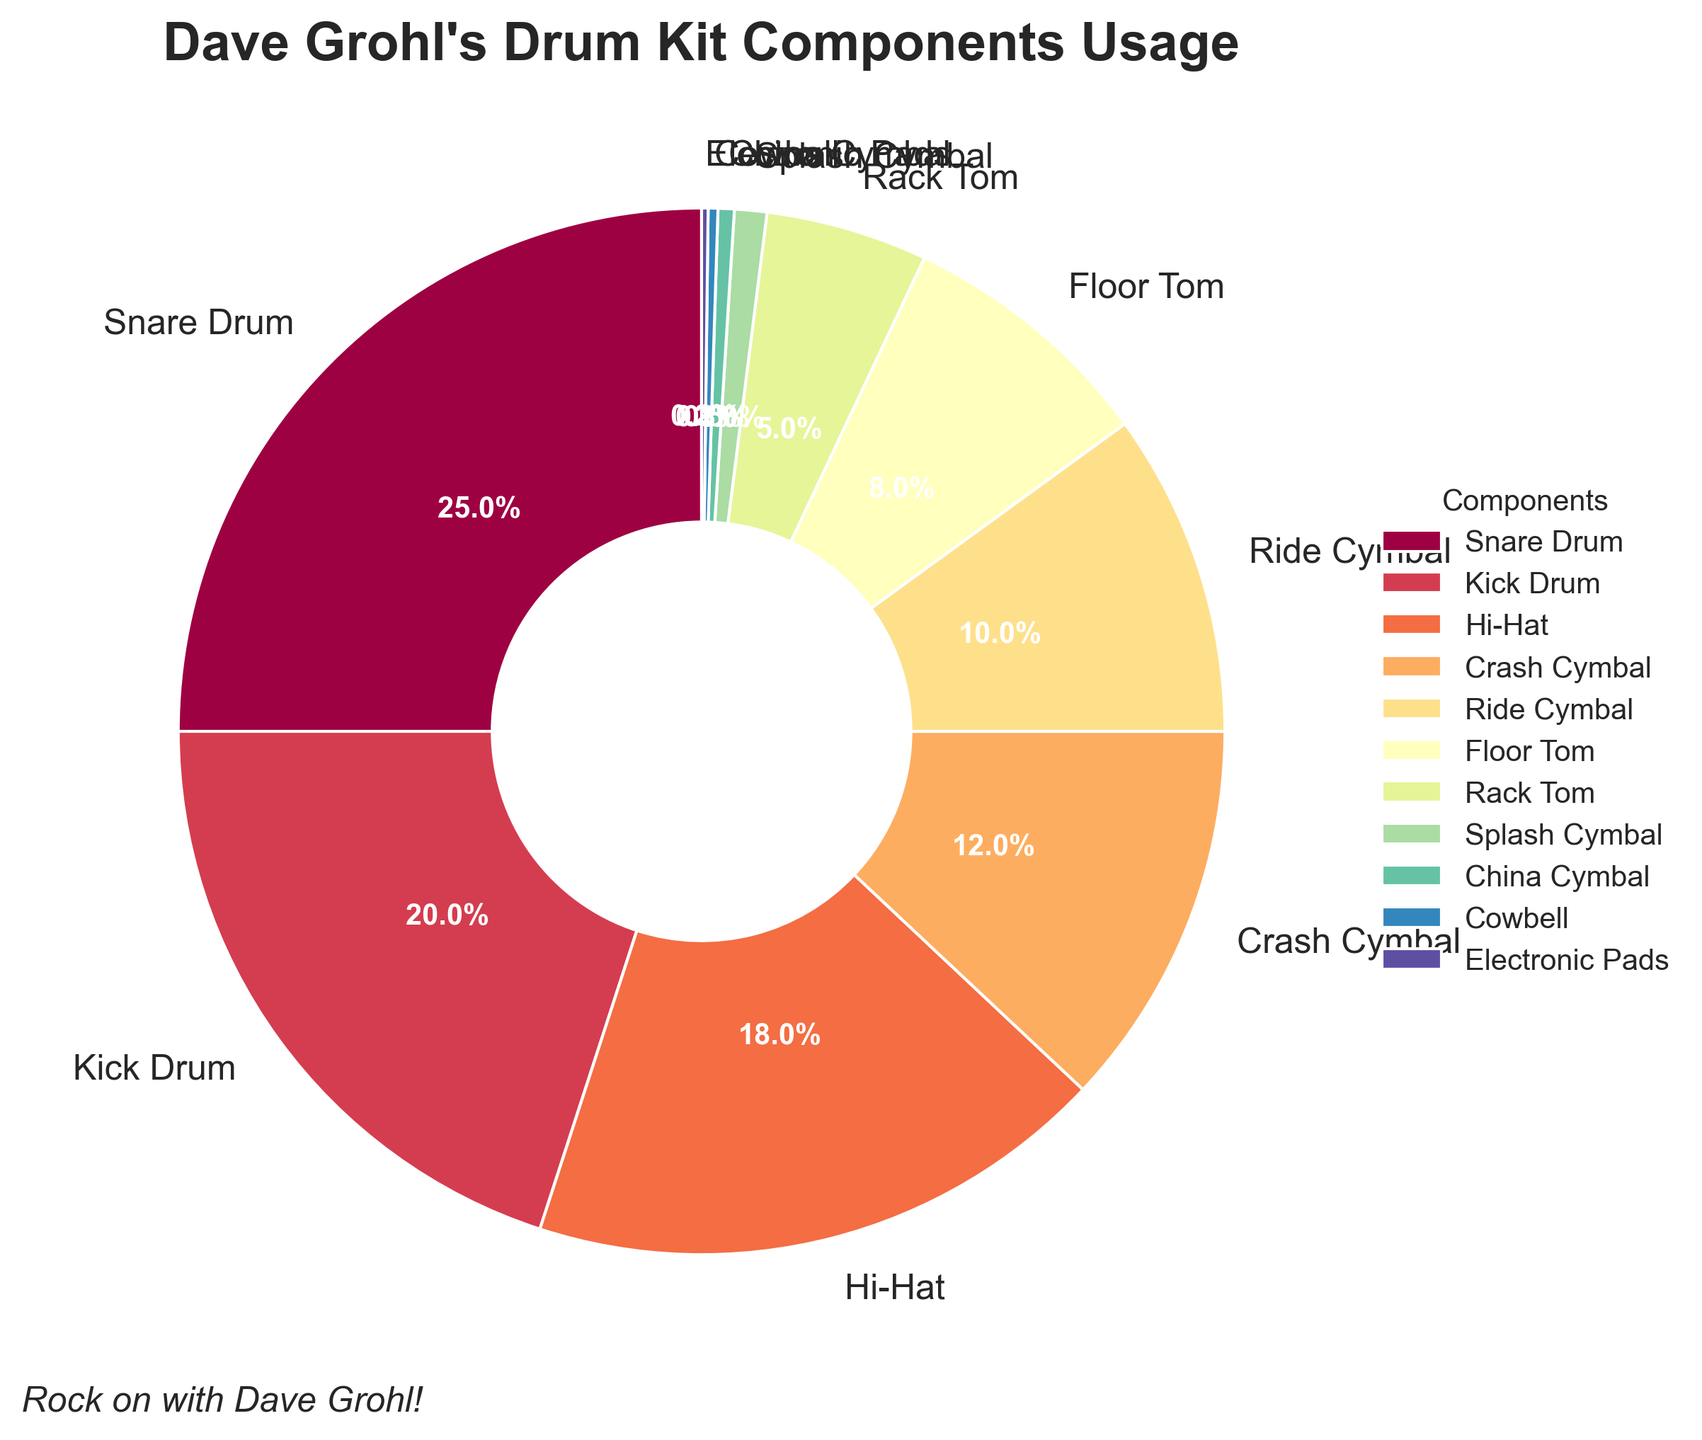Which component does Dave Grohl use the most in his recordings? To find out which component is used the most, we look for the largest percentage in the figure. The Snare Drum has the highest percentage at 25%.
Answer: Snare Drum Which three components contribute the most to the overall usage, and what is their combined percentage? Identify the three largest percentages in the chart: Snare Drum (25%), Kick Drum (20%), and Hi-Hat (18%). Add these percentages: 25% + 20% + 18% = 63%.
Answer: Snare Drum, Kick Drum, Hi-Hat; 63% Is the usage of the Crash Cymbal greater than that of the Ride Cymbal? Compare the percentages for Crash Cymbal (12%) and Ride Cymbal (10%). Since 12% is greater than 10%, the Crash Cymbal is used more than the Ride Cymbal.
Answer: Yes How much more is the Snare Drum used compared to the Kick Drum? Subtract the percentage of the Kick Drum (20%) from the percentage of the Snare Drum (25%): 25% - 20% = 5%.
Answer: 5% What is the visual color of the Hi-Hat section in the pie chart? Identify the color used for the Hi-Hat section in the pie chart. The Hi-Hat can be distinguished by the spectral color mapping used.
Answer: (Assuming knowledge of spectral color palette mapping, typically yellow/orange) What is the total percentage contribution of all cymbals combined? Sum the percentages of all the cymbal components: Crash Cymbal (12%), Ride Cymbal (10%), Splash Cymbal (1%), and China Cymbal (0.5%): 12% + 10% + 1% + 0.5% = 23.5%.
Answer: 23.5% Which component has the smallest usage and what is its percentage? Identify the component with the smallest percentage in the chart. The Electronic Pads has the smallest usage at 0.2%.
Answer: Electronic Pads; 0.2% If you combine the usage of the Floor Tom and Rack Tom, does their total usage exceed that of the Crash Cymbal? Add the percentages of the Floor Tom (8%) and Rack Tom (5%): 8% + 5% = 13%. Compare it to Crash Cymbal's usage (12%). 13% > 12%, so the combined usage of Floor Tom and Rack Tom exceeds that of Crash Cymbal.
Answer: Yes What is the difference in percentage between the usage of the Hi-Hat and the Ride Cymbal? Subtract the percentage of the Ride Cymbal (10%) from the percentage of the Hi-Hat (18%): 18% - 10% = 8%.
Answer: 8% 